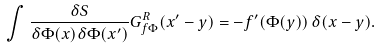<formula> <loc_0><loc_0><loc_500><loc_500>\int \frac { \delta S } { \delta \Phi ( x ) \delta \Phi ( x ^ { \prime } ) } G ^ { R } _ { f \Phi } ( x ^ { \prime } - y ) = - f ^ { \prime } ( \Phi ( y ) ) \, \delta ( x - y ) .</formula> 